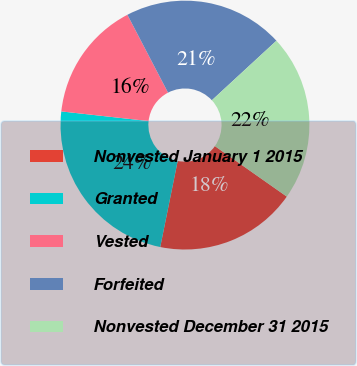Convert chart to OTSL. <chart><loc_0><loc_0><loc_500><loc_500><pie_chart><fcel>Nonvested January 1 2015<fcel>Granted<fcel>Vested<fcel>Forfeited<fcel>Nonvested December 31 2015<nl><fcel>18.44%<fcel>23.57%<fcel>15.59%<fcel>20.8%<fcel>21.6%<nl></chart> 